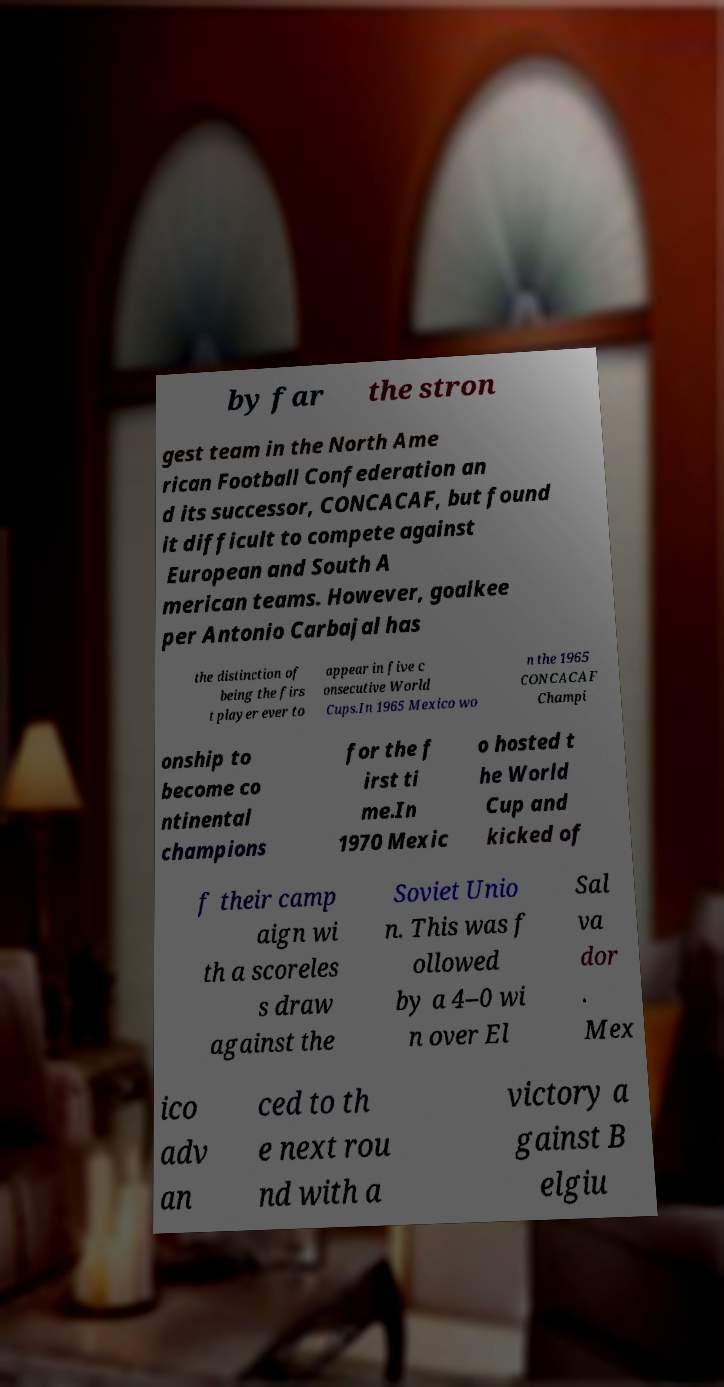Please identify and transcribe the text found in this image. by far the stron gest team in the North Ame rican Football Confederation an d its successor, CONCACAF, but found it difficult to compete against European and South A merican teams. However, goalkee per Antonio Carbajal has the distinction of being the firs t player ever to appear in five c onsecutive World Cups.In 1965 Mexico wo n the 1965 CONCACAF Champi onship to become co ntinental champions for the f irst ti me.In 1970 Mexic o hosted t he World Cup and kicked of f their camp aign wi th a scoreles s draw against the Soviet Unio n. This was f ollowed by a 4–0 wi n over El Sal va dor . Mex ico adv an ced to th e next rou nd with a victory a gainst B elgiu 